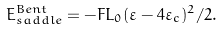Convert formula to latex. <formula><loc_0><loc_0><loc_500><loc_500>E _ { s a d d l e } ^ { B e n t } = - { F L _ { 0 } } ( \varepsilon - 4 \varepsilon _ { c } ) ^ { 2 } / 2 .</formula> 